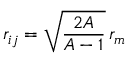Convert formula to latex. <formula><loc_0><loc_0><loc_500><loc_500>r _ { i j } = \sqrt { \frac { 2 A } { A - 1 } } \, r _ { m }</formula> 